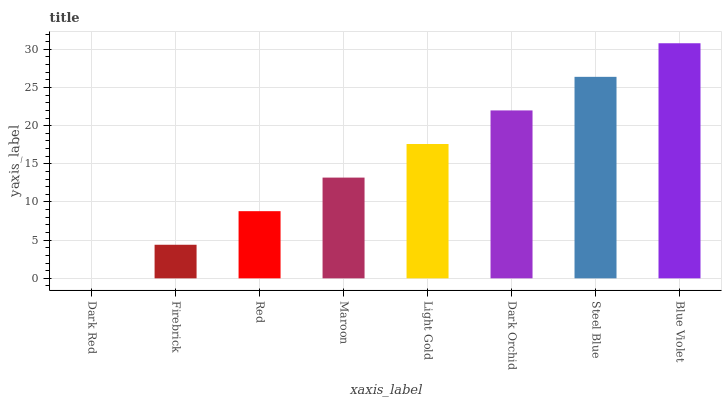Is Firebrick the minimum?
Answer yes or no. No. Is Firebrick the maximum?
Answer yes or no. No. Is Firebrick greater than Dark Red?
Answer yes or no. Yes. Is Dark Red less than Firebrick?
Answer yes or no. Yes. Is Dark Red greater than Firebrick?
Answer yes or no. No. Is Firebrick less than Dark Red?
Answer yes or no. No. Is Light Gold the high median?
Answer yes or no. Yes. Is Maroon the low median?
Answer yes or no. Yes. Is Maroon the high median?
Answer yes or no. No. Is Firebrick the low median?
Answer yes or no. No. 